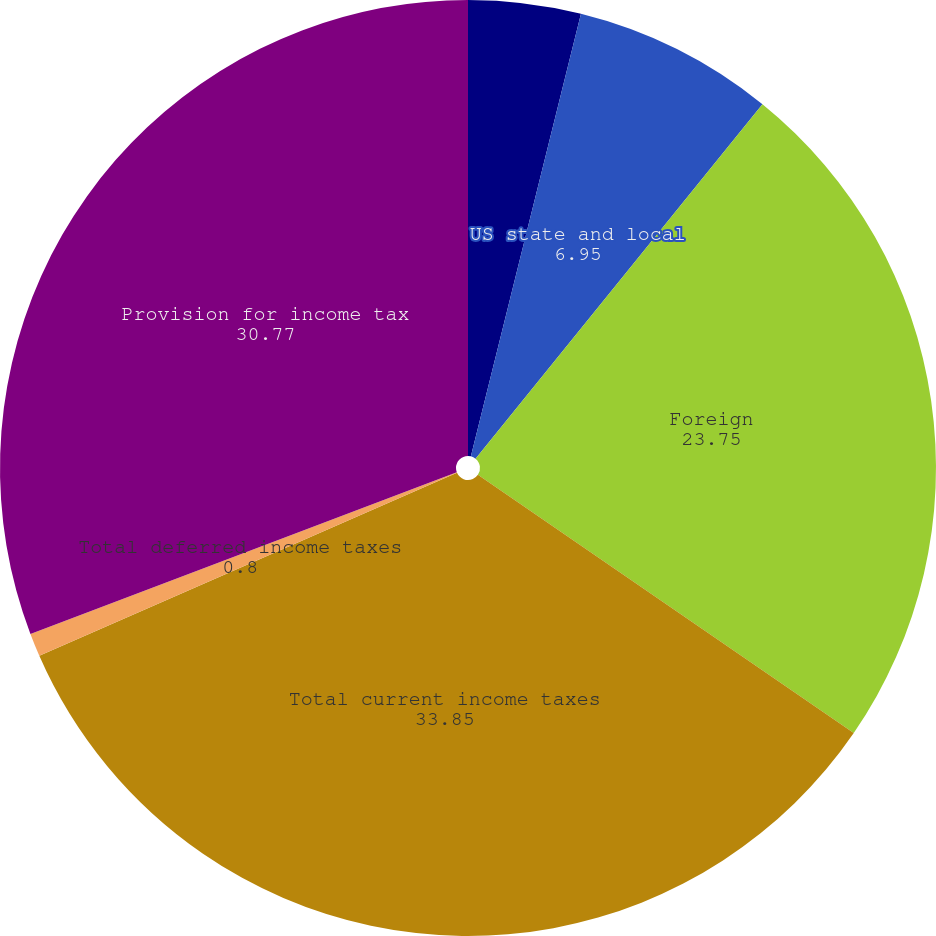Convert chart to OTSL. <chart><loc_0><loc_0><loc_500><loc_500><pie_chart><fcel>US federal<fcel>US state and local<fcel>Foreign<fcel>Total current income taxes<fcel>Total deferred income taxes<fcel>Provision for income tax<nl><fcel>3.88%<fcel>6.95%<fcel>23.75%<fcel>33.85%<fcel>0.8%<fcel>30.77%<nl></chart> 